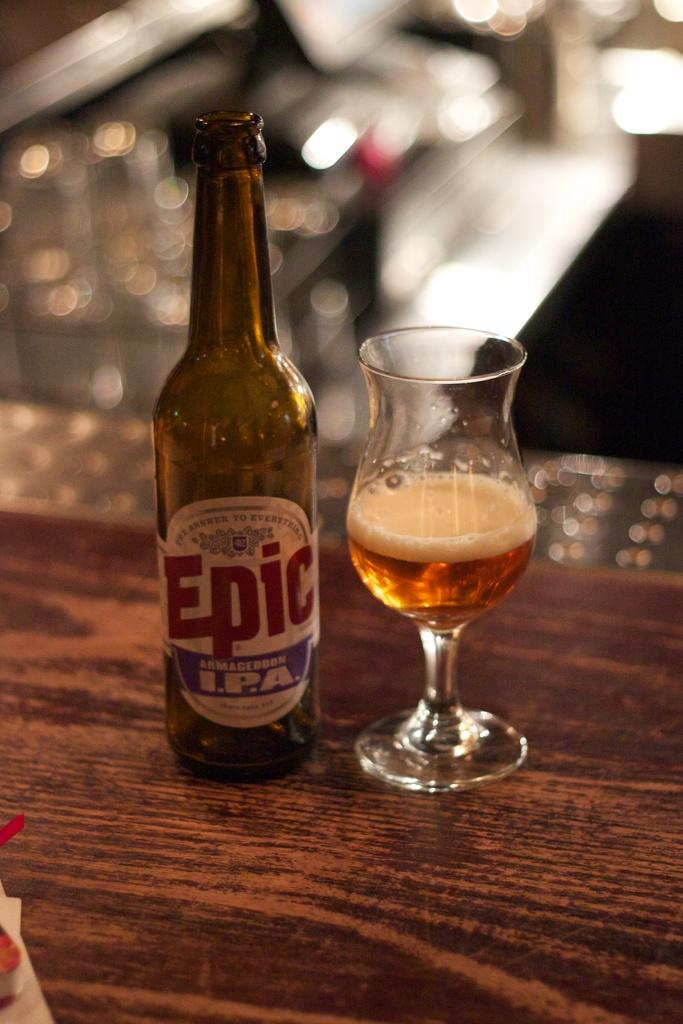What is the main object in the image? There is a bottle in the image. What other object is near the bottle? There is a glass beside the bottle in the image. Where are the bottle and glass located? Both the bottle and the glass are on a table. What type of pipe can be seen connecting the bottle and the glass in the image? There is no pipe connecting the bottle and the glass in the image. 